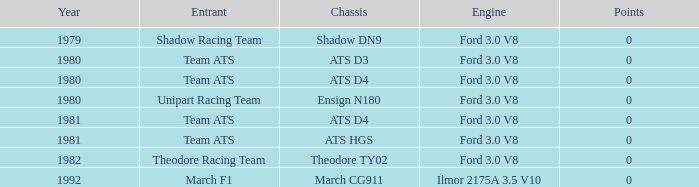What was the lowest year that the engine Ilmor 2175a 3.5 v10 was used? 1992.0. 